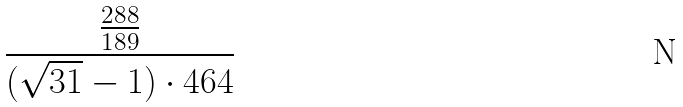<formula> <loc_0><loc_0><loc_500><loc_500>\frac { \frac { 2 8 8 } { 1 8 9 } } { ( \sqrt { 3 1 } - 1 ) \cdot 4 6 4 }</formula> 